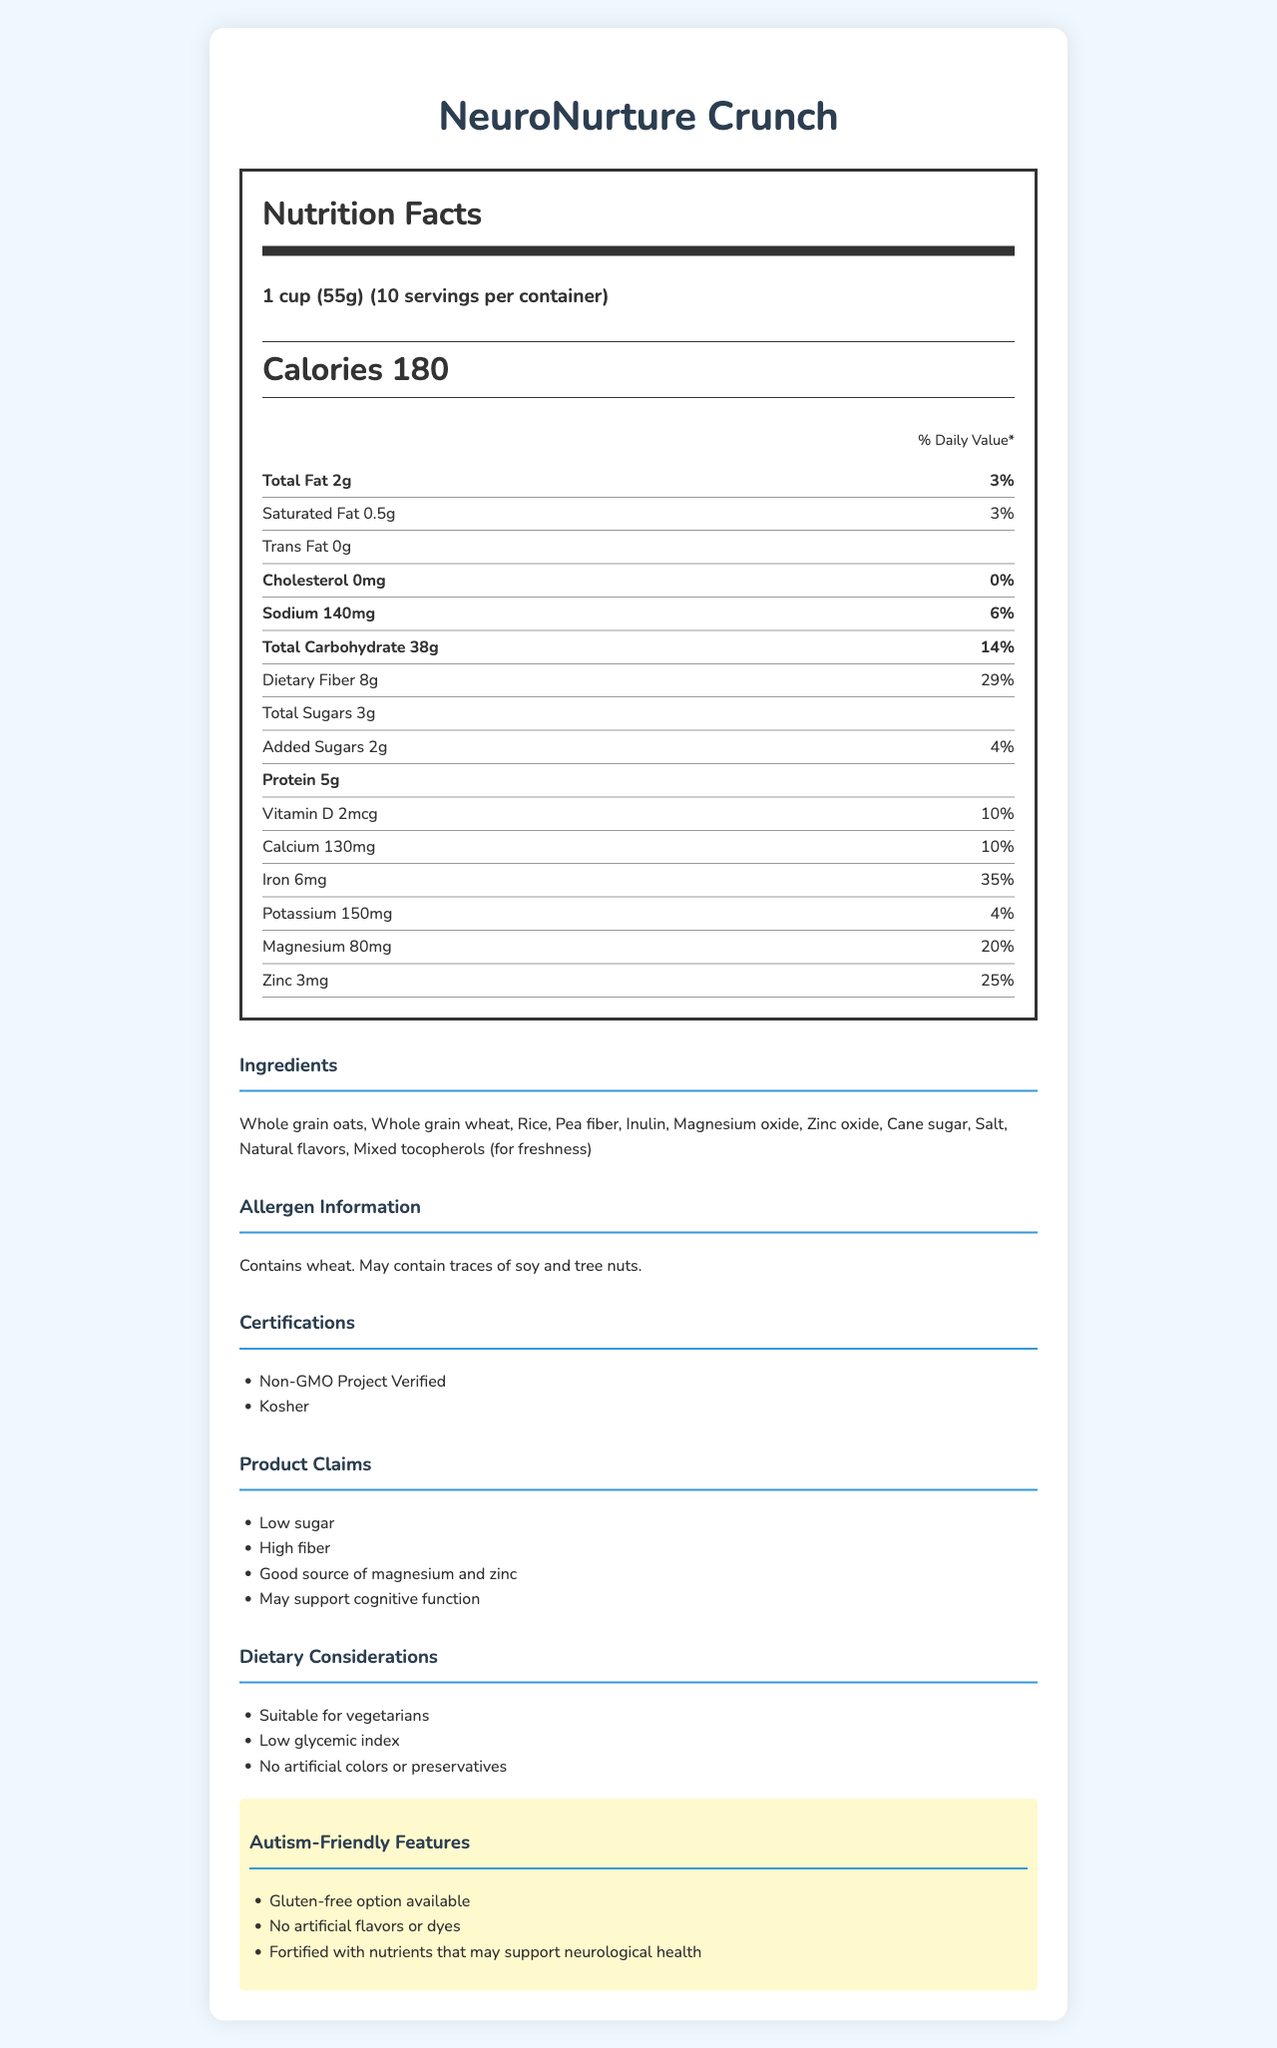what is the serving size of NeuroNurture Crunch? The serving size information is clearly stated under the Nutrition Facts header as "1 cup (55g)".
Answer: 1 cup (55g) how many servings are in one container of NeuroNurture Crunch? The document specifies that there are 10 servings per container under the Nutrition Facts header.
Answer: 10 servings what is the total amount of dietary fiber per serving? The document indicates that each serving contains 8 grams of dietary fiber.
Answer: 8g list two main ingredients in NeuroNurture Crunch. The ingredients list starts with "Whole grain oats" and "Whole grain wheat".
Answer: Whole grain oats, Whole grain wheat what percentage of the daily value of magnesium does one serving provide? The listed daily value for magnesium is 20% for each serving, as shown in the Nutrition Facts.
Answer: 20% which nutrient's daily value is the highest? A. Fiber B. Iron C. Magnesium D. Sodium Iron's daily value is listed as 35%, which is higher than fiber (29%), magnesium (20%), and sodium (6%).
Answer: B which certification does NeuroNurture Crunch NOT have? A. Non-GMO Project Verified B. Kosher C. Gluten-Free Certified D. Organic The listed certifications are "Non-GMO Project Verified" and "Kosher". Gluten-Free Certified and Organic are not listed under the certifications.
Answer: C is NeuroNurture Crunch suitable for vegetarians? It is indicated under dietary considerations that the product is suitable for vegetarians.
Answer: Yes does NeuroNurture Crunch contain any artificial colors or preservatives? The document states that the product has no artificial colors or preservatives.
Answer: No summarize the main features of NeuroNurture Crunch. The main features are outlined under multiple sections such as Nutrition Facts, ingredients, allergen information, certifications, claims, dietary considerations, and autism-friendly features.
Answer: NeuroNurture Crunch is a low-sugar, high-fiber breakfast cereal with added magnesium and zinc. It provides various nutrients, is suitable for vegetarians, and is fortified with nutrients that may support neurological health. This product has certifications like Non-GMO and Kosher and no artificial flavors, colors, or preservatives. how much sugar is added to NeuroNurture Crunch? The amount of added sugars per serving is listed as 2g in the document.
Answer: 2g can it be determined if NeuroNurture Crunch is gluten-free from the document? The document mentions a gluten-free option is available but does not specify if this particular product is gluten-free.
Answer: No/Not enough information 